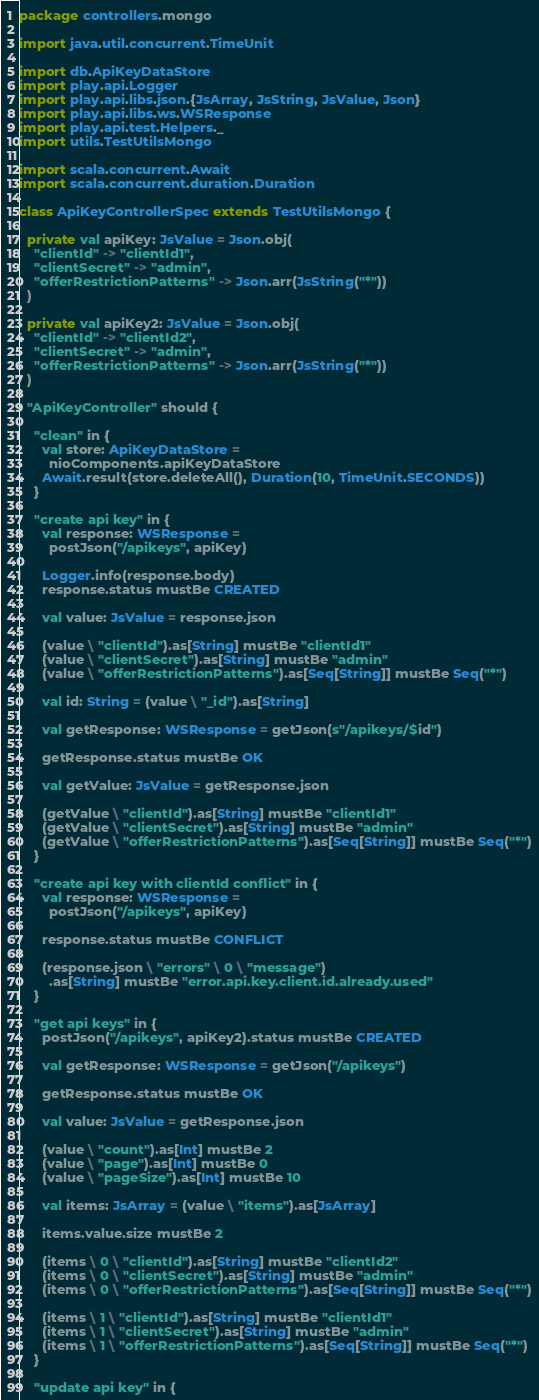<code> <loc_0><loc_0><loc_500><loc_500><_Scala_>package controllers.mongo

import java.util.concurrent.TimeUnit

import db.ApiKeyDataStore
import play.api.Logger
import play.api.libs.json.{JsArray, JsString, JsValue, Json}
import play.api.libs.ws.WSResponse
import play.api.test.Helpers._
import utils.TestUtilsMongo

import scala.concurrent.Await
import scala.concurrent.duration.Duration

class ApiKeyControllerSpec extends TestUtilsMongo {

  private val apiKey: JsValue = Json.obj(
    "clientId" -> "clientId1",
    "clientSecret" -> "admin",
    "offerRestrictionPatterns" -> Json.arr(JsString("*"))
  )

  private val apiKey2: JsValue = Json.obj(
    "clientId" -> "clientId2",
    "clientSecret" -> "admin",
    "offerRestrictionPatterns" -> Json.arr(JsString("*"))
  )

  "ApiKeyController" should {

    "clean" in {
      val store: ApiKeyDataStore =
        nioComponents.apiKeyDataStore
      Await.result(store.deleteAll(), Duration(10, TimeUnit.SECONDS))
    }

    "create api key" in {
      val response: WSResponse =
        postJson("/apikeys", apiKey)

      Logger.info(response.body)
      response.status mustBe CREATED

      val value: JsValue = response.json

      (value \ "clientId").as[String] mustBe "clientId1"
      (value \ "clientSecret").as[String] mustBe "admin"
      (value \ "offerRestrictionPatterns").as[Seq[String]] mustBe Seq("*")

      val id: String = (value \ "_id").as[String]

      val getResponse: WSResponse = getJson(s"/apikeys/$id")

      getResponse.status mustBe OK

      val getValue: JsValue = getResponse.json

      (getValue \ "clientId").as[String] mustBe "clientId1"
      (getValue \ "clientSecret").as[String] mustBe "admin"
      (getValue \ "offerRestrictionPatterns").as[Seq[String]] mustBe Seq("*")
    }

    "create api key with clientId conflict" in {
      val response: WSResponse =
        postJson("/apikeys", apiKey)

      response.status mustBe CONFLICT

      (response.json \ "errors" \ 0 \ "message")
        .as[String] mustBe "error.api.key.client.id.already.used"
    }

    "get api keys" in {
      postJson("/apikeys", apiKey2).status mustBe CREATED

      val getResponse: WSResponse = getJson("/apikeys")

      getResponse.status mustBe OK

      val value: JsValue = getResponse.json

      (value \ "count").as[Int] mustBe 2
      (value \ "page").as[Int] mustBe 0
      (value \ "pageSize").as[Int] mustBe 10

      val items: JsArray = (value \ "items").as[JsArray]

      items.value.size mustBe 2

      (items \ 0 \ "clientId").as[String] mustBe "clientId2"
      (items \ 0 \ "clientSecret").as[String] mustBe "admin"
      (items \ 0 \ "offerRestrictionPatterns").as[Seq[String]] mustBe Seq("*")

      (items \ 1 \ "clientId").as[String] mustBe "clientId1"
      (items \ 1 \ "clientSecret").as[String] mustBe "admin"
      (items \ 1 \ "offerRestrictionPatterns").as[Seq[String]] mustBe Seq("*")
    }

    "update api key" in {
</code> 